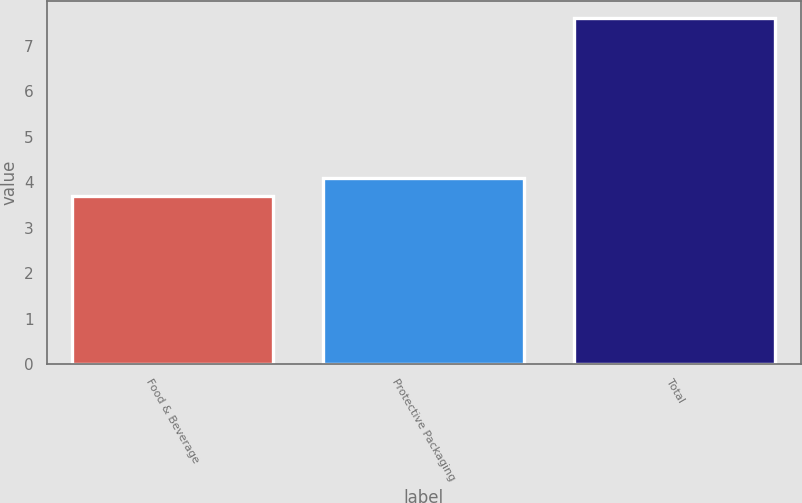Convert chart. <chart><loc_0><loc_0><loc_500><loc_500><bar_chart><fcel>Food & Beverage<fcel>Protective Packaging<fcel>Total<nl><fcel>3.7<fcel>4.09<fcel>7.6<nl></chart> 